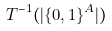<formula> <loc_0><loc_0><loc_500><loc_500>T ^ { - 1 } ( | \{ 0 , 1 \} ^ { A } | )</formula> 